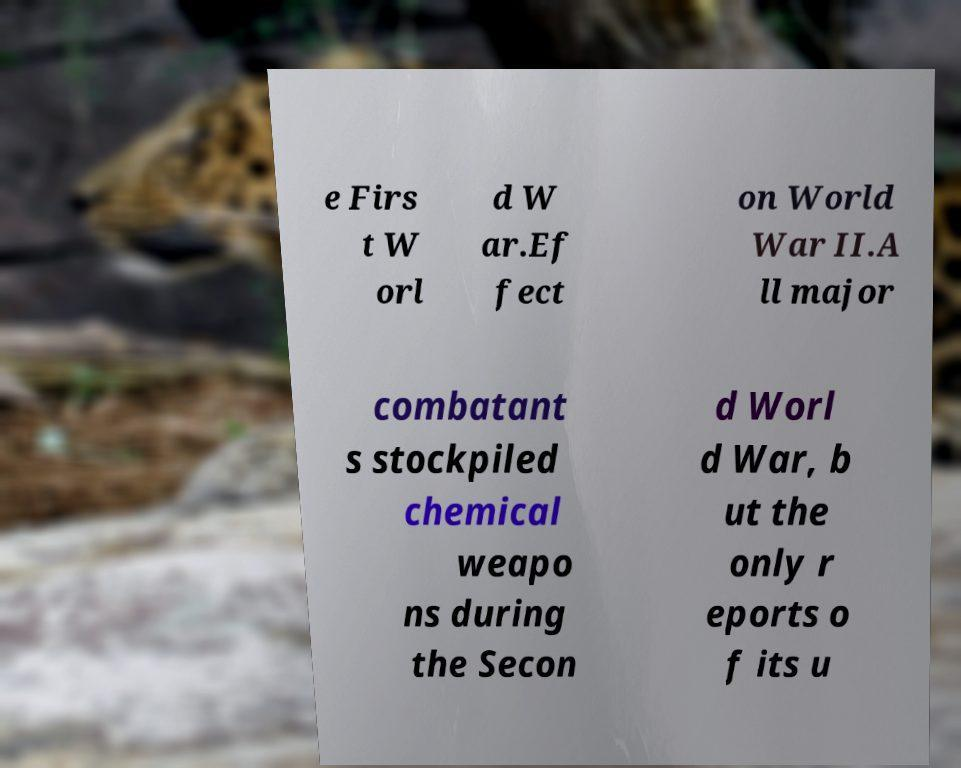I need the written content from this picture converted into text. Can you do that? e Firs t W orl d W ar.Ef fect on World War II.A ll major combatant s stockpiled chemical weapo ns during the Secon d Worl d War, b ut the only r eports o f its u 